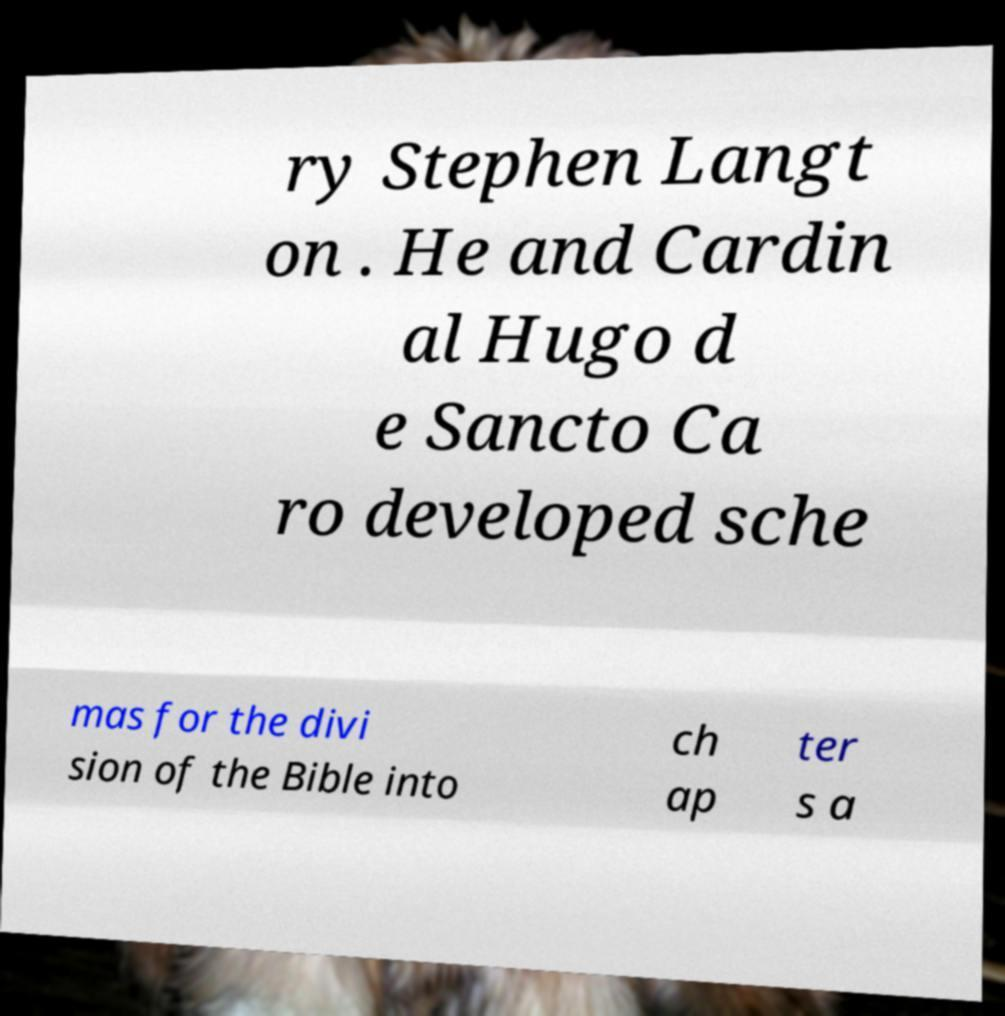Please read and relay the text visible in this image. What does it say? ry Stephen Langt on . He and Cardin al Hugo d e Sancto Ca ro developed sche mas for the divi sion of the Bible into ch ap ter s a 